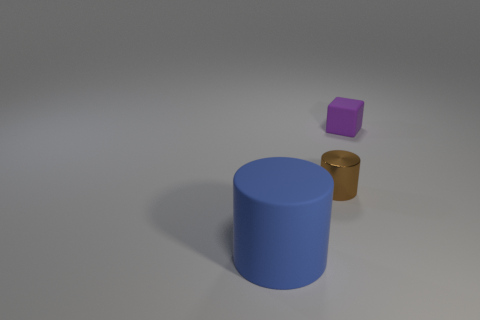Add 3 large gray matte balls. How many objects exist? 6 Subtract all blocks. How many objects are left? 2 Subtract 1 brown cylinders. How many objects are left? 2 Subtract all cylinders. Subtract all tiny cylinders. How many objects are left? 0 Add 1 small purple blocks. How many small purple blocks are left? 2 Add 3 purple things. How many purple things exist? 4 